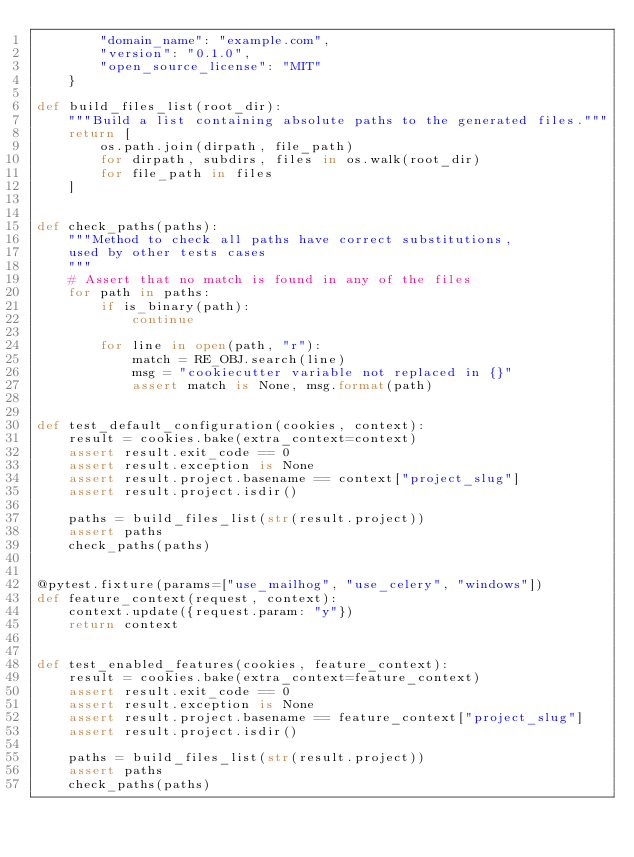<code> <loc_0><loc_0><loc_500><loc_500><_Python_>        "domain_name": "example.com",
        "version": "0.1.0",
        "open_source_license": "MIT"
    }

def build_files_list(root_dir):
    """Build a list containing absolute paths to the generated files."""
    return [
        os.path.join(dirpath, file_path)
        for dirpath, subdirs, files in os.walk(root_dir)
        for file_path in files
    ]


def check_paths(paths):
    """Method to check all paths have correct substitutions,
    used by other tests cases
    """
    # Assert that no match is found in any of the files
    for path in paths:
        if is_binary(path):
            continue

        for line in open(path, "r"):
            match = RE_OBJ.search(line)
            msg = "cookiecutter variable not replaced in {}"
            assert match is None, msg.format(path)


def test_default_configuration(cookies, context):
    result = cookies.bake(extra_context=context)
    assert result.exit_code == 0
    assert result.exception is None
    assert result.project.basename == context["project_slug"]
    assert result.project.isdir()

    paths = build_files_list(str(result.project))
    assert paths
    check_paths(paths)


@pytest.fixture(params=["use_mailhog", "use_celery", "windows"])
def feature_context(request, context):
    context.update({request.param: "y"})
    return context


def test_enabled_features(cookies, feature_context):
    result = cookies.bake(extra_context=feature_context)
    assert result.exit_code == 0
    assert result.exception is None
    assert result.project.basename == feature_context["project_slug"]
    assert result.project.isdir()

    paths = build_files_list(str(result.project))
    assert paths
    check_paths(paths)
</code> 